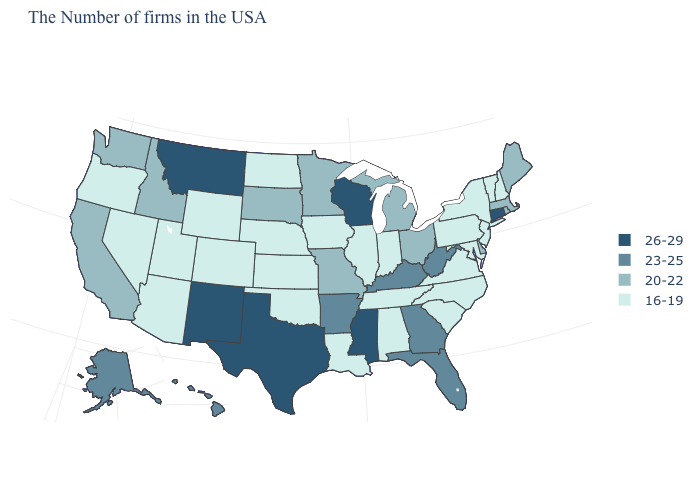Name the states that have a value in the range 26-29?
Keep it brief. Connecticut, Wisconsin, Mississippi, Texas, New Mexico, Montana. Which states have the lowest value in the West?
Be succinct. Wyoming, Colorado, Utah, Arizona, Nevada, Oregon. Name the states that have a value in the range 26-29?
Answer briefly. Connecticut, Wisconsin, Mississippi, Texas, New Mexico, Montana. Name the states that have a value in the range 16-19?
Answer briefly. New Hampshire, Vermont, New York, New Jersey, Maryland, Pennsylvania, Virginia, North Carolina, South Carolina, Indiana, Alabama, Tennessee, Illinois, Louisiana, Iowa, Kansas, Nebraska, Oklahoma, North Dakota, Wyoming, Colorado, Utah, Arizona, Nevada, Oregon. What is the value of North Carolina?
Quick response, please. 16-19. Name the states that have a value in the range 26-29?
Answer briefly. Connecticut, Wisconsin, Mississippi, Texas, New Mexico, Montana. Name the states that have a value in the range 16-19?
Write a very short answer. New Hampshire, Vermont, New York, New Jersey, Maryland, Pennsylvania, Virginia, North Carolina, South Carolina, Indiana, Alabama, Tennessee, Illinois, Louisiana, Iowa, Kansas, Nebraska, Oklahoma, North Dakota, Wyoming, Colorado, Utah, Arizona, Nevada, Oregon. Name the states that have a value in the range 16-19?
Answer briefly. New Hampshire, Vermont, New York, New Jersey, Maryland, Pennsylvania, Virginia, North Carolina, South Carolina, Indiana, Alabama, Tennessee, Illinois, Louisiana, Iowa, Kansas, Nebraska, Oklahoma, North Dakota, Wyoming, Colorado, Utah, Arizona, Nevada, Oregon. What is the value of Massachusetts?
Answer briefly. 20-22. Name the states that have a value in the range 20-22?
Quick response, please. Maine, Massachusetts, Rhode Island, Delaware, Ohio, Michigan, Missouri, Minnesota, South Dakota, Idaho, California, Washington. What is the value of North Dakota?
Write a very short answer. 16-19. Among the states that border Oklahoma , which have the lowest value?
Keep it brief. Kansas, Colorado. Name the states that have a value in the range 23-25?
Concise answer only. West Virginia, Florida, Georgia, Kentucky, Arkansas, Alaska, Hawaii. What is the value of Maryland?
Short answer required. 16-19. 